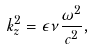Convert formula to latex. <formula><loc_0><loc_0><loc_500><loc_500>k _ { z } ^ { 2 } = \epsilon \nu \frac { \omega ^ { 2 } } { c ^ { 2 } } ,</formula> 